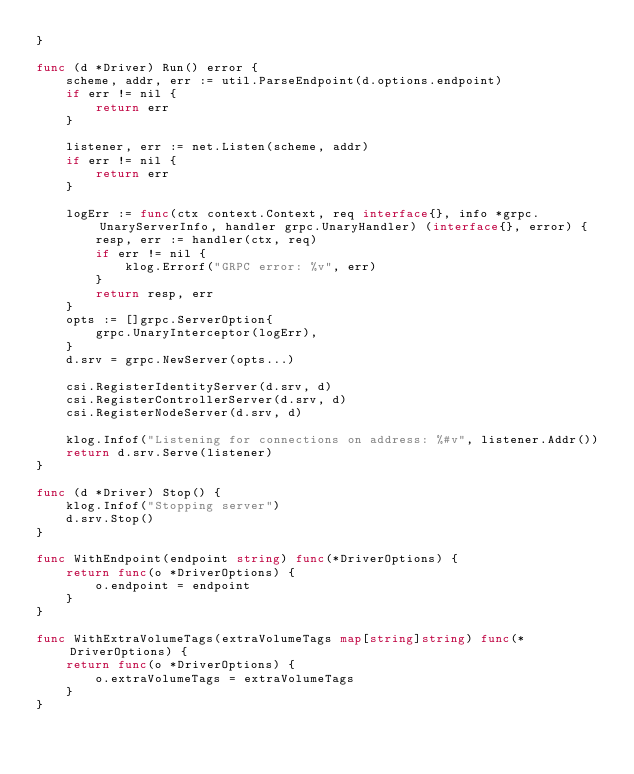<code> <loc_0><loc_0><loc_500><loc_500><_Go_>}

func (d *Driver) Run() error {
	scheme, addr, err := util.ParseEndpoint(d.options.endpoint)
	if err != nil {
		return err
	}

	listener, err := net.Listen(scheme, addr)
	if err != nil {
		return err
	}

	logErr := func(ctx context.Context, req interface{}, info *grpc.UnaryServerInfo, handler grpc.UnaryHandler) (interface{}, error) {
		resp, err := handler(ctx, req)
		if err != nil {
			klog.Errorf("GRPC error: %v", err)
		}
		return resp, err
	}
	opts := []grpc.ServerOption{
		grpc.UnaryInterceptor(logErr),
	}
	d.srv = grpc.NewServer(opts...)

	csi.RegisterIdentityServer(d.srv, d)
	csi.RegisterControllerServer(d.srv, d)
	csi.RegisterNodeServer(d.srv, d)

	klog.Infof("Listening for connections on address: %#v", listener.Addr())
	return d.srv.Serve(listener)
}

func (d *Driver) Stop() {
	klog.Infof("Stopping server")
	d.srv.Stop()
}

func WithEndpoint(endpoint string) func(*DriverOptions) {
	return func(o *DriverOptions) {
		o.endpoint = endpoint
	}
}

func WithExtraVolumeTags(extraVolumeTags map[string]string) func(*DriverOptions) {
	return func(o *DriverOptions) {
		o.extraVolumeTags = extraVolumeTags
	}
}
</code> 